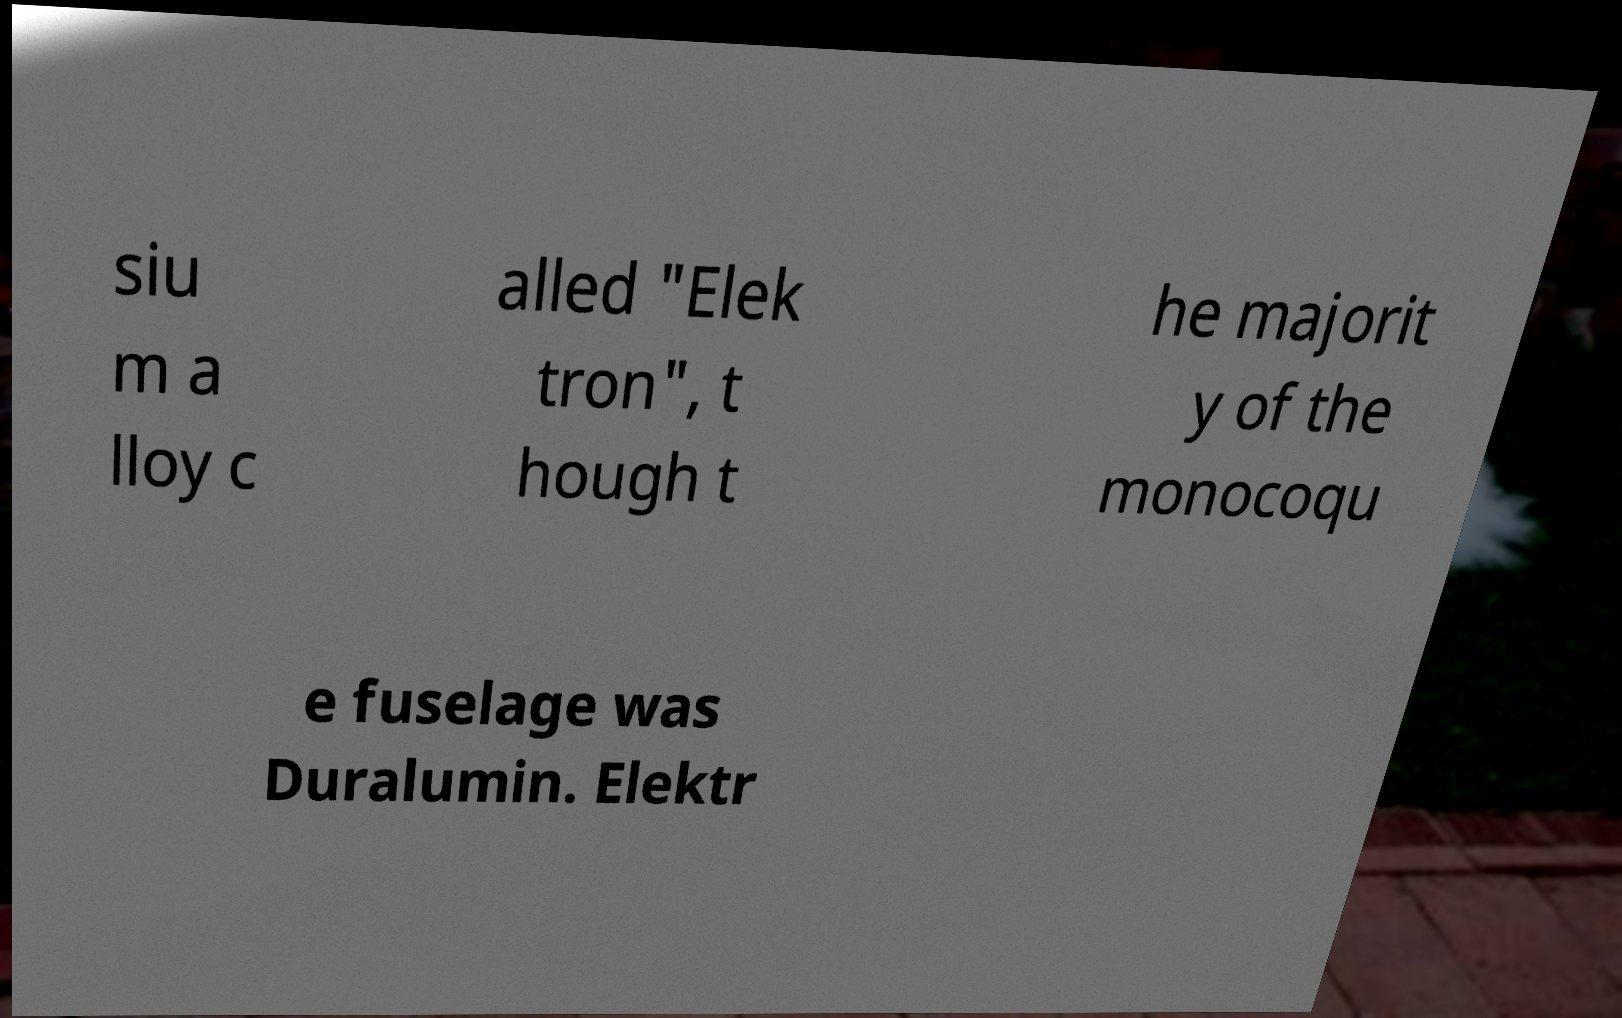Can you read and provide the text displayed in the image?This photo seems to have some interesting text. Can you extract and type it out for me? siu m a lloy c alled "Elek tron", t hough t he majorit y of the monocoqu e fuselage was Duralumin. Elektr 